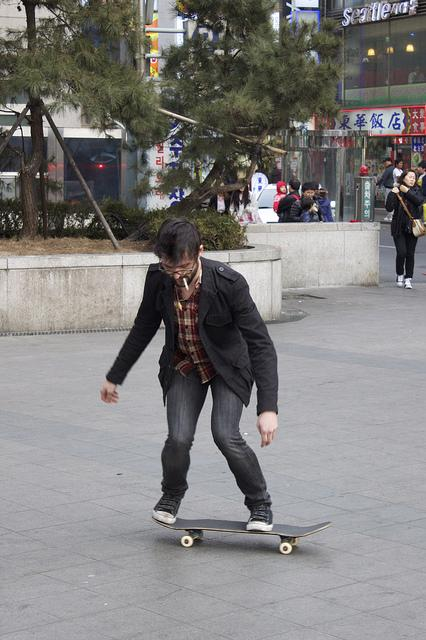What part of his body will be most harmed by the item in his mouth? lungs 